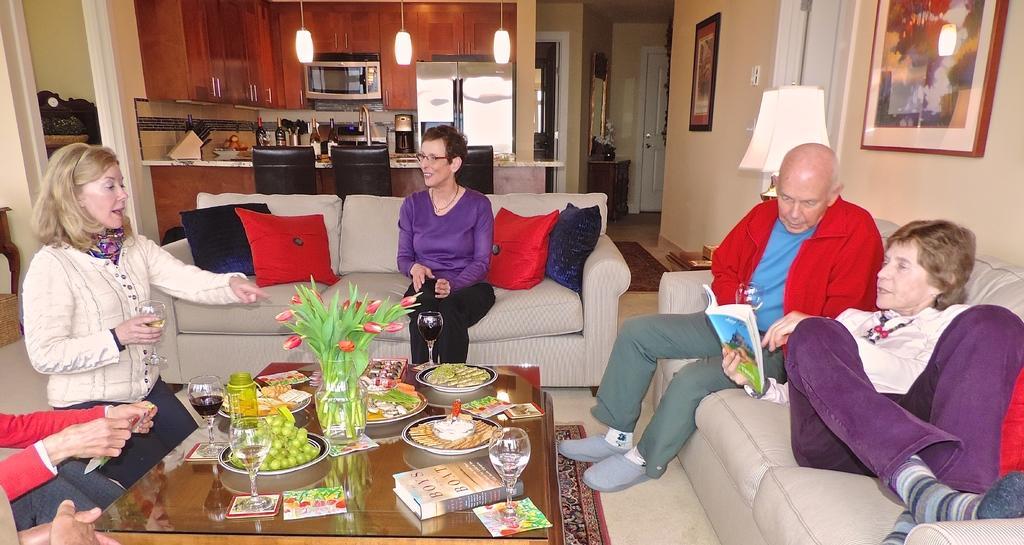Could you give a brief overview of what you see in this image? This image is clicked in a home. On the there are two people on the sofa. In the middle there is a table on the table there are many items. On the left there is a woman her hair is short ,she is speaking something. In the middle there is a sofa on that there is a woman. In the background there is a refrigerator,light and chairs. 